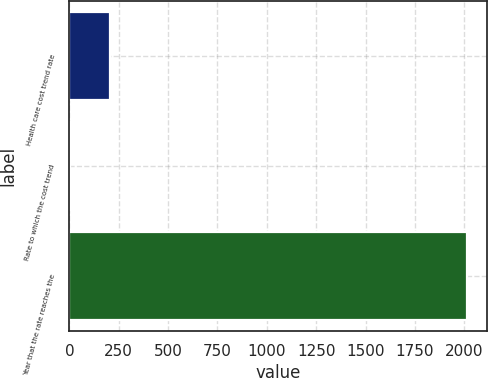<chart> <loc_0><loc_0><loc_500><loc_500><bar_chart><fcel>Health care cost trend rate<fcel>Rate to which the cost trend<fcel>Year that the rate reaches the<nl><fcel>205.7<fcel>5<fcel>2012<nl></chart> 